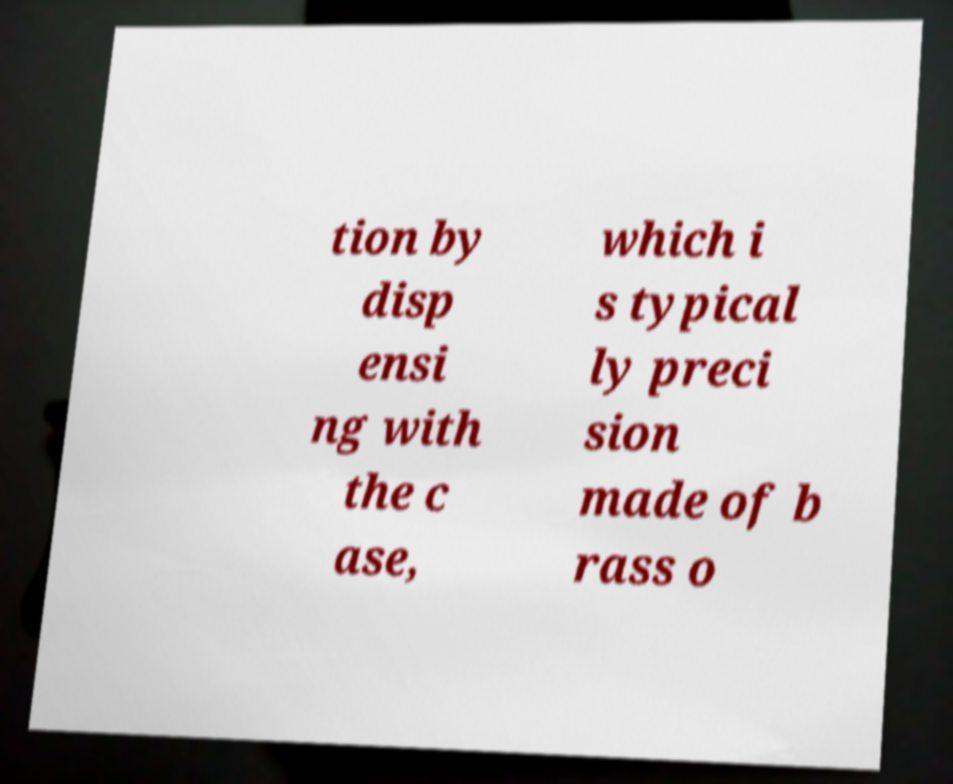Please identify and transcribe the text found in this image. tion by disp ensi ng with the c ase, which i s typical ly preci sion made of b rass o 